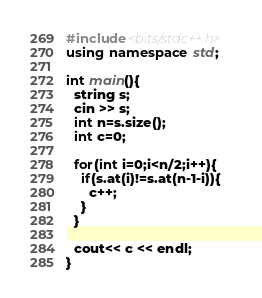<code> <loc_0><loc_0><loc_500><loc_500><_C++_>#include<bits/stdc++.h>
using namespace std;

int main(){
  string s;
  cin >> s;
  int n=s.size();
  int c=0;
  
  for(int i=0;i<n/2;i++){
    if(s.at(i)!=s.at(n-1-i)){
      c++;
    }
  }
       
  cout<< c << endl;
}</code> 